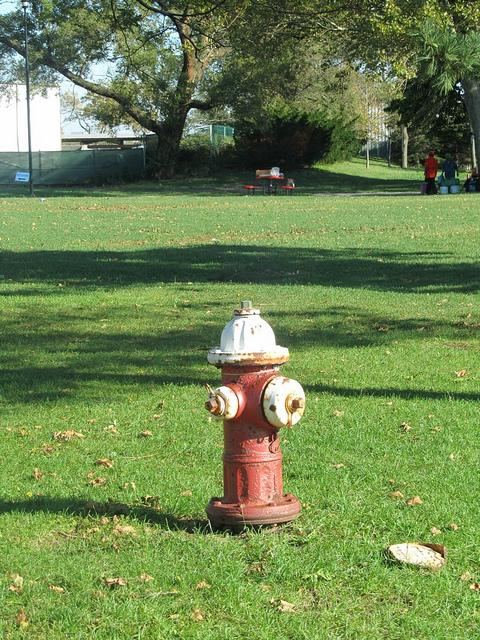Where is the fire hydrant located? park 